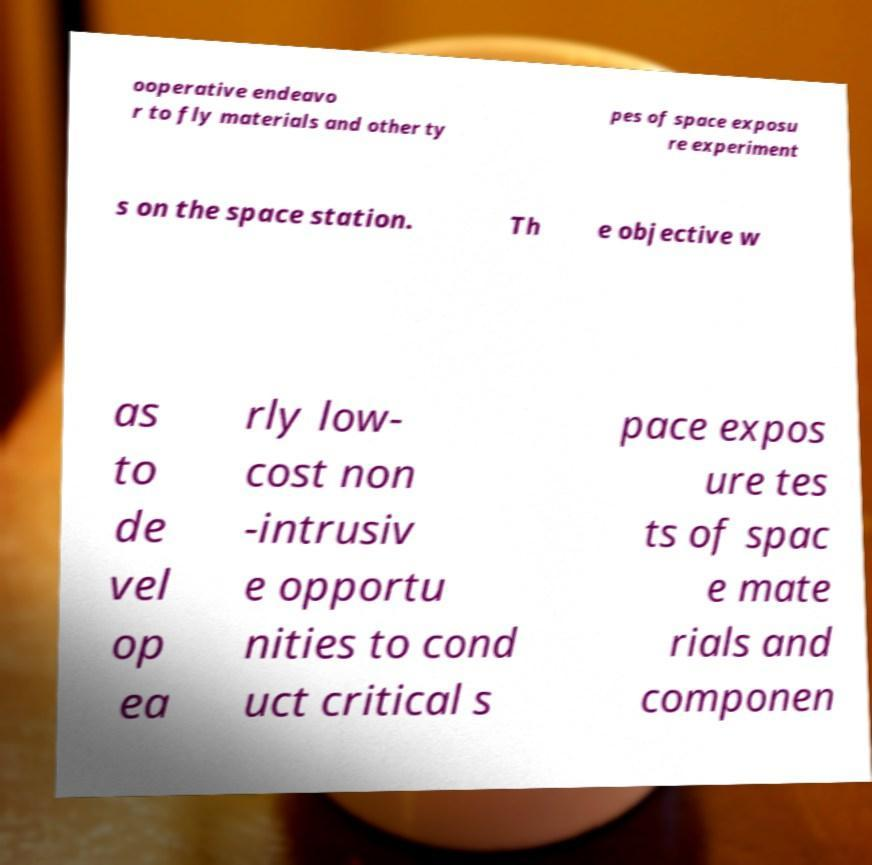There's text embedded in this image that I need extracted. Can you transcribe it verbatim? ooperative endeavo r to fly materials and other ty pes of space exposu re experiment s on the space station. Th e objective w as to de vel op ea rly low- cost non -intrusiv e opportu nities to cond uct critical s pace expos ure tes ts of spac e mate rials and componen 